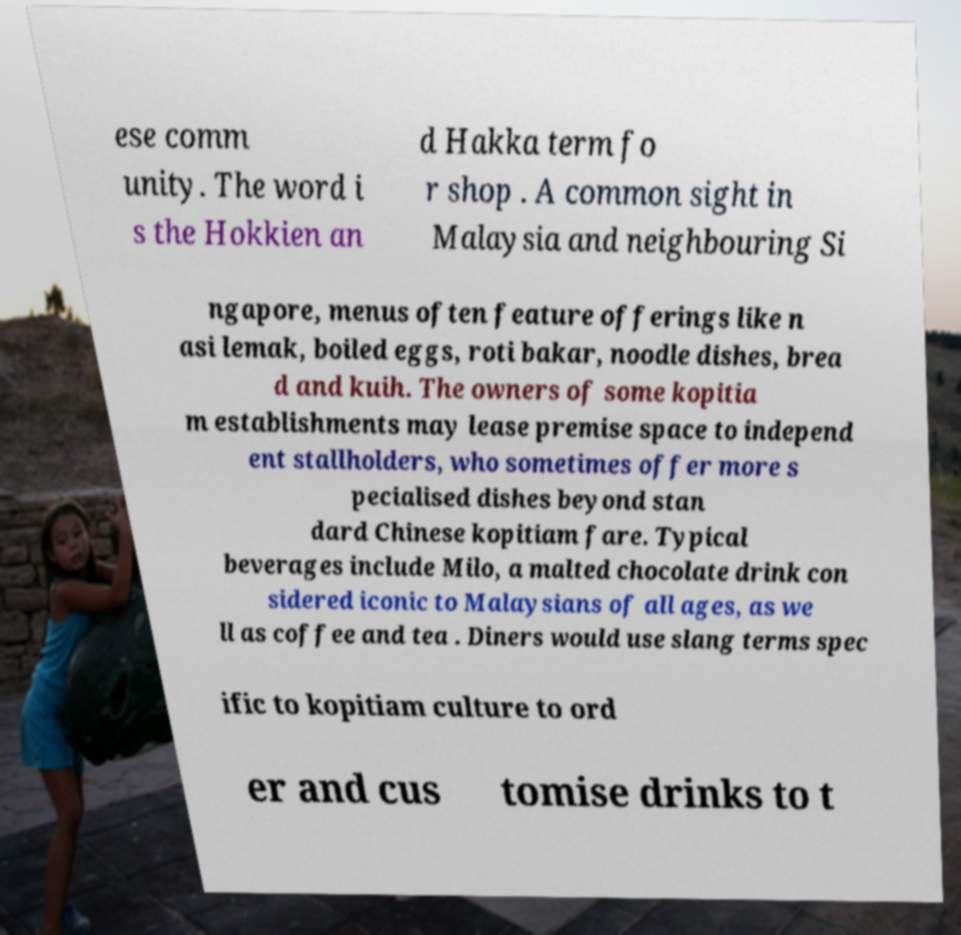Could you assist in decoding the text presented in this image and type it out clearly? ese comm unity. The word i s the Hokkien an d Hakka term fo r shop . A common sight in Malaysia and neighbouring Si ngapore, menus often feature offerings like n asi lemak, boiled eggs, roti bakar, noodle dishes, brea d and kuih. The owners of some kopitia m establishments may lease premise space to independ ent stallholders, who sometimes offer more s pecialised dishes beyond stan dard Chinese kopitiam fare. Typical beverages include Milo, a malted chocolate drink con sidered iconic to Malaysians of all ages, as we ll as coffee and tea . Diners would use slang terms spec ific to kopitiam culture to ord er and cus tomise drinks to t 